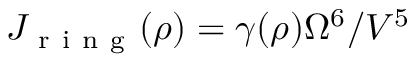<formula> <loc_0><loc_0><loc_500><loc_500>J _ { r i n g } ( \rho ) = \gamma ( \rho ) \Omega ^ { 6 } / V ^ { 5 }</formula> 